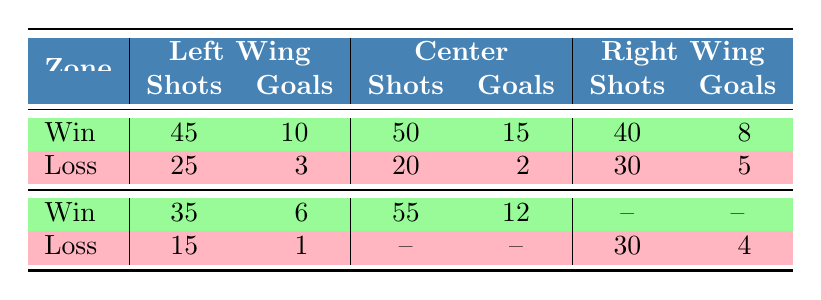What is the total number of shots on goal for teams that won the game? To find the total number of shots on goal for winning teams, add the shots from the "Win" rows: 45 (New York Rangers) + 50 (Chicago Blackhawks) + 35 (Florida Panthers) + 55 (Pittsburgh Penguins) + 40 (Boston Bruins) = 225.
Answer: 225 Which zone had the highest number of goals scored by winning teams? From the "Win" rows, the goals scored are: Left Wing - 10 (New York Rangers), Center - 15 (Chicago Blackhawks), Right Wing - 8 (Boston Bruins), and Left Wing - 6 (Florida Panthers). The highest is 15 goals by the Center zone.
Answer: Center How many total goals did losing teams score from the Left Wing zone? The losing teams scored from the Left Wing: 3 (Los Angeles Kings) and 1 (Montreal Canadiens), so when added, 3 + 1 = 4 goals scored by losing teams in the Left Wing zone.
Answer: 4 Did any team score more goals than shots in the Center zone? Analyzing the Center zone: Chicago Blackhawks scored 15 goals with 50 shots (yes), while San Jose Sharks scored 2 goals with 20 shots (no). Overall, only the Chicago Blackhawks scored more goals than shots.
Answer: Yes What is the average number of shots on goal for winning teams in the Left Wing zone? The winning teams in the Left Wing zone are New York Rangers (45 shots) and Florida Panthers (35 shots). Sum of shots is 45 + 35 = 80, and there are 2 teams, so the average is 80/2 = 40.
Answer: 40 